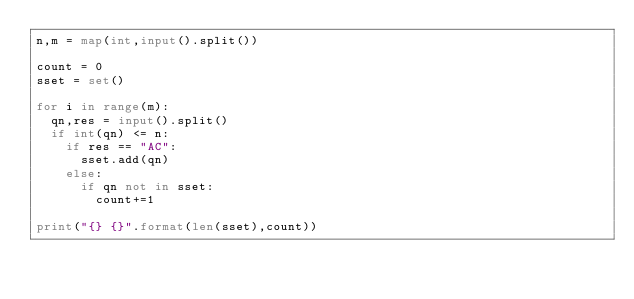<code> <loc_0><loc_0><loc_500><loc_500><_Python_>n,m = map(int,input().split())
 
count = 0
sset = set()
 
for i in range(m):
  qn,res = input().split()
  if int(qn) <= n:
    if res == "AC":
      sset.add(qn)
    else:
      if qn not in sset:
        count+=1
      
print("{} {}".format(len(sset),count))</code> 